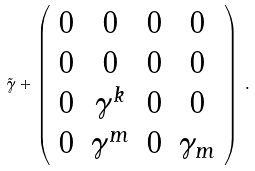Convert formula to latex. <formula><loc_0><loc_0><loc_500><loc_500>\tilde { \gamma } + \left ( \begin{array} { c c c c } 0 & 0 & 0 & 0 \\ 0 & 0 & 0 & 0 \\ 0 & \gamma ^ { k } & 0 & 0 \\ 0 & \gamma ^ { m } & 0 & \gamma _ { m } \end{array} \right ) \, .</formula> 